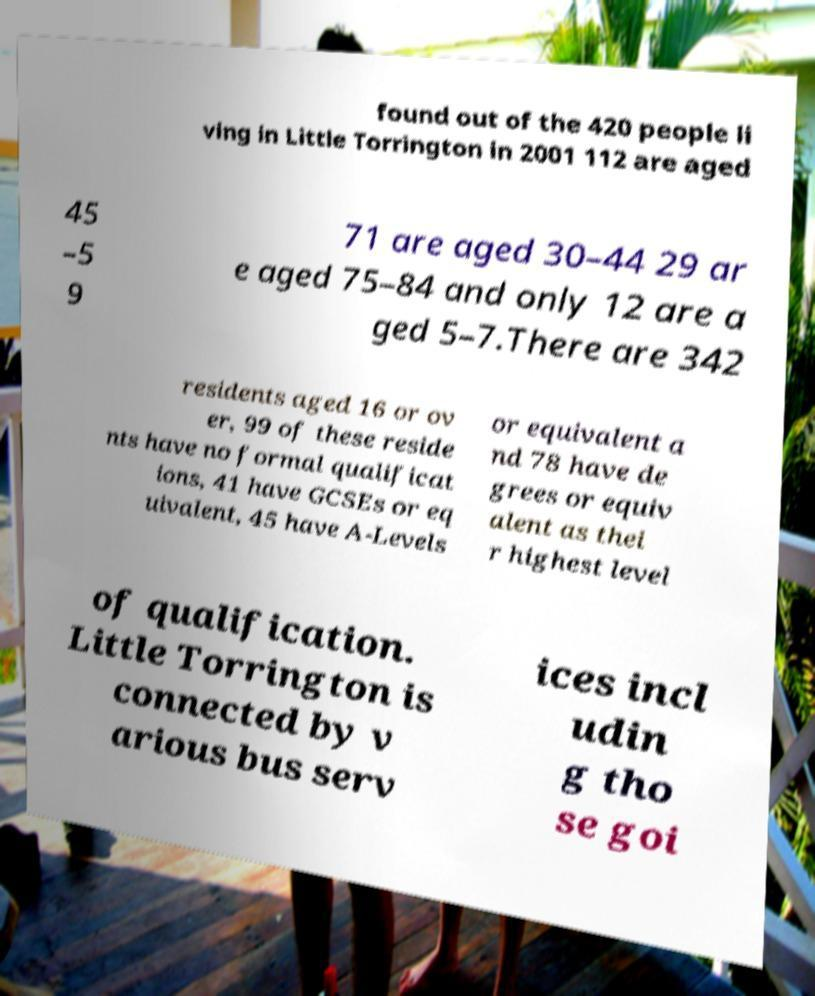Can you read and provide the text displayed in the image?This photo seems to have some interesting text. Can you extract and type it out for me? found out of the 420 people li ving in Little Torrington in 2001 112 are aged 45 –5 9 71 are aged 30–44 29 ar e aged 75–84 and only 12 are a ged 5–7.There are 342 residents aged 16 or ov er, 99 of these reside nts have no formal qualificat ions, 41 have GCSEs or eq uivalent, 45 have A-Levels or equivalent a nd 78 have de grees or equiv alent as thei r highest level of qualification. Little Torrington is connected by v arious bus serv ices incl udin g tho se goi 